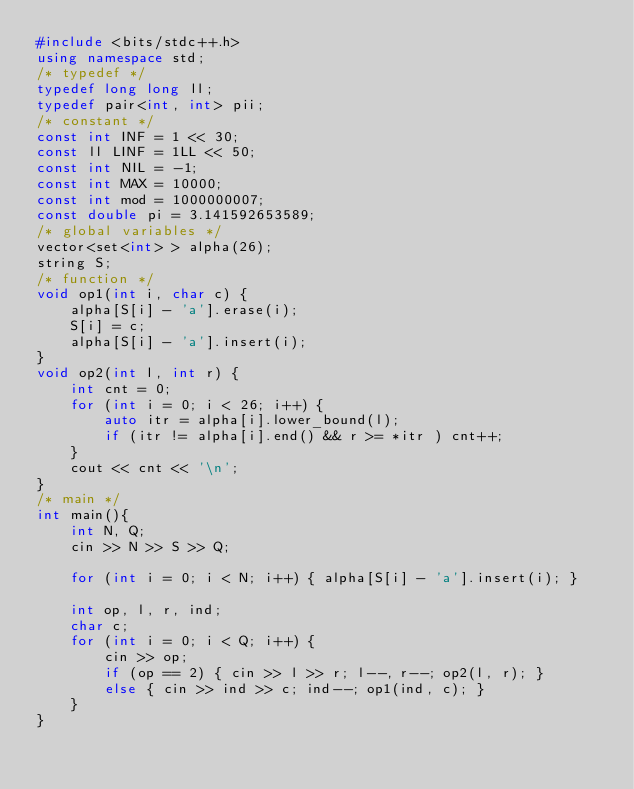<code> <loc_0><loc_0><loc_500><loc_500><_C++_>#include <bits/stdc++.h>
using namespace std;
/* typedef */
typedef long long ll;
typedef pair<int, int> pii;
/* constant */
const int INF = 1 << 30;
const ll LINF = 1LL << 50;
const int NIL = -1;
const int MAX = 10000;
const int mod = 1000000007;
const double pi = 3.141592653589;
/* global variables */
vector<set<int> > alpha(26);
string S;
/* function */
void op1(int i, char c) {
    alpha[S[i] - 'a'].erase(i);
    S[i] = c;
    alpha[S[i] - 'a'].insert(i);
}
void op2(int l, int r) {
    int cnt = 0;
    for (int i = 0; i < 26; i++) {
        auto itr = alpha[i].lower_bound(l);
        if (itr != alpha[i].end() && r >= *itr ) cnt++;
    }
    cout << cnt << '\n';
}
/* main */
int main(){
    int N, Q;
    cin >> N >> S >> Q;

    for (int i = 0; i < N; i++) { alpha[S[i] - 'a'].insert(i); }

    int op, l, r, ind;
    char c;
    for (int i = 0; i < Q; i++) {
        cin >> op;
        if (op == 2) { cin >> l >> r; l--, r--; op2(l, r); }
        else { cin >> ind >> c; ind--; op1(ind, c); }
    }
}
</code> 